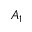Convert formula to latex. <formula><loc_0><loc_0><loc_500><loc_500>A _ { 1 }</formula> 